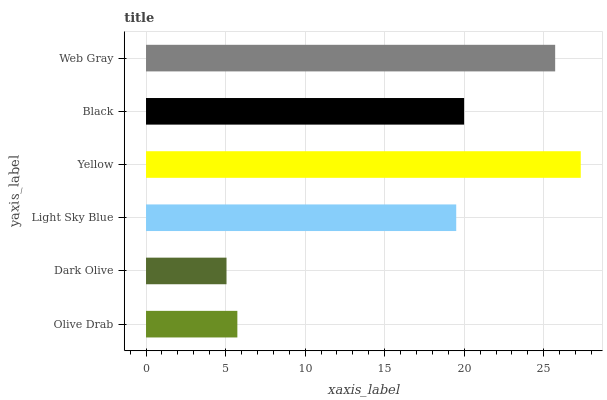Is Dark Olive the minimum?
Answer yes or no. Yes. Is Yellow the maximum?
Answer yes or no. Yes. Is Light Sky Blue the minimum?
Answer yes or no. No. Is Light Sky Blue the maximum?
Answer yes or no. No. Is Light Sky Blue greater than Dark Olive?
Answer yes or no. Yes. Is Dark Olive less than Light Sky Blue?
Answer yes or no. Yes. Is Dark Olive greater than Light Sky Blue?
Answer yes or no. No. Is Light Sky Blue less than Dark Olive?
Answer yes or no. No. Is Black the high median?
Answer yes or no. Yes. Is Light Sky Blue the low median?
Answer yes or no. Yes. Is Olive Drab the high median?
Answer yes or no. No. Is Web Gray the low median?
Answer yes or no. No. 